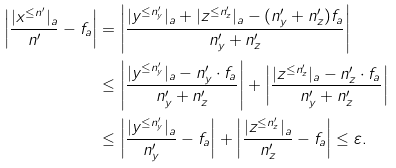Convert formula to latex. <formula><loc_0><loc_0><loc_500><loc_500>\left | \frac { | x ^ { \leq n ^ { \prime } } | _ { a } } { n ^ { \prime } } - f _ { a } \right | & = \left | \frac { | y ^ { \leq n ^ { \prime } _ { y } } | _ { a } + | z ^ { \leq n ^ { \prime } _ { z } } | _ { a } - ( n ^ { \prime } _ { y } + n ^ { \prime } _ { z } ) f _ { a } } { n ^ { \prime } _ { y } + n ^ { \prime } _ { z } } \right | \\ & \leq \left | \frac { | y ^ { \leq n ^ { \prime } _ { y } } | _ { a } - n ^ { \prime } _ { y } \cdot f _ { a } } { n ^ { \prime } _ { y } + n ^ { \prime } _ { z } } \right | + \left | \frac { | z ^ { \leq n ^ { \prime } _ { z } } | _ { a } - n ^ { \prime } _ { z } \cdot f _ { a } } { n ^ { \prime } _ { y } + n ^ { \prime } _ { z } } \right | \\ & \leq \left | \frac { | y ^ { \leq n ^ { \prime } _ { y } } | _ { a } } { n ^ { \prime } _ { y } } - f _ { a } \right | + \left | \frac { | z ^ { \leq n ^ { \prime } _ { z } } | _ { a } } { n ^ { \prime } _ { z } } - f _ { a } \right | \leq \varepsilon .</formula> 